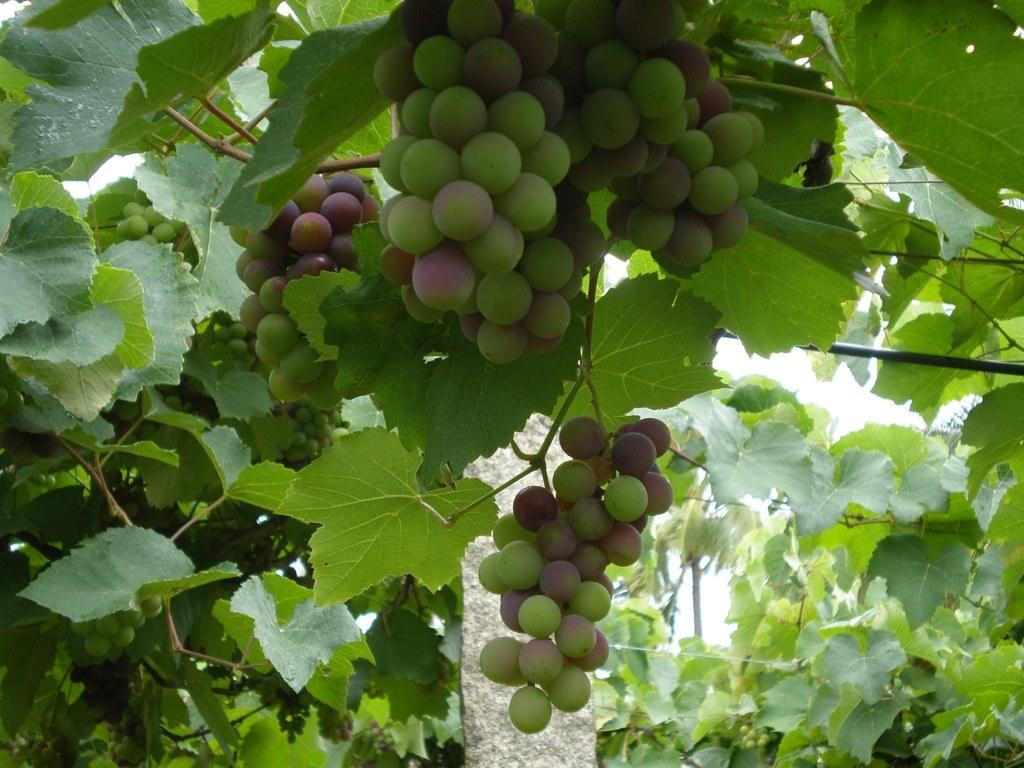What type of plant is visible in the image? There is a plant in the image, but the specific type cannot be determined from the provided facts. What else can be seen in the image besides the plant? There are fruits visible in the image. What object is located towards the bottom of the image? There is a stone towards the bottom of the image. What color is the background of the image? The background of the image is white in color. Can you see the ocean in the image? No, there is no ocean present in the image. What type of glass is being used to hold the fruits in the image? There is no glass visible in the image; the fruits are not being held in any container. 